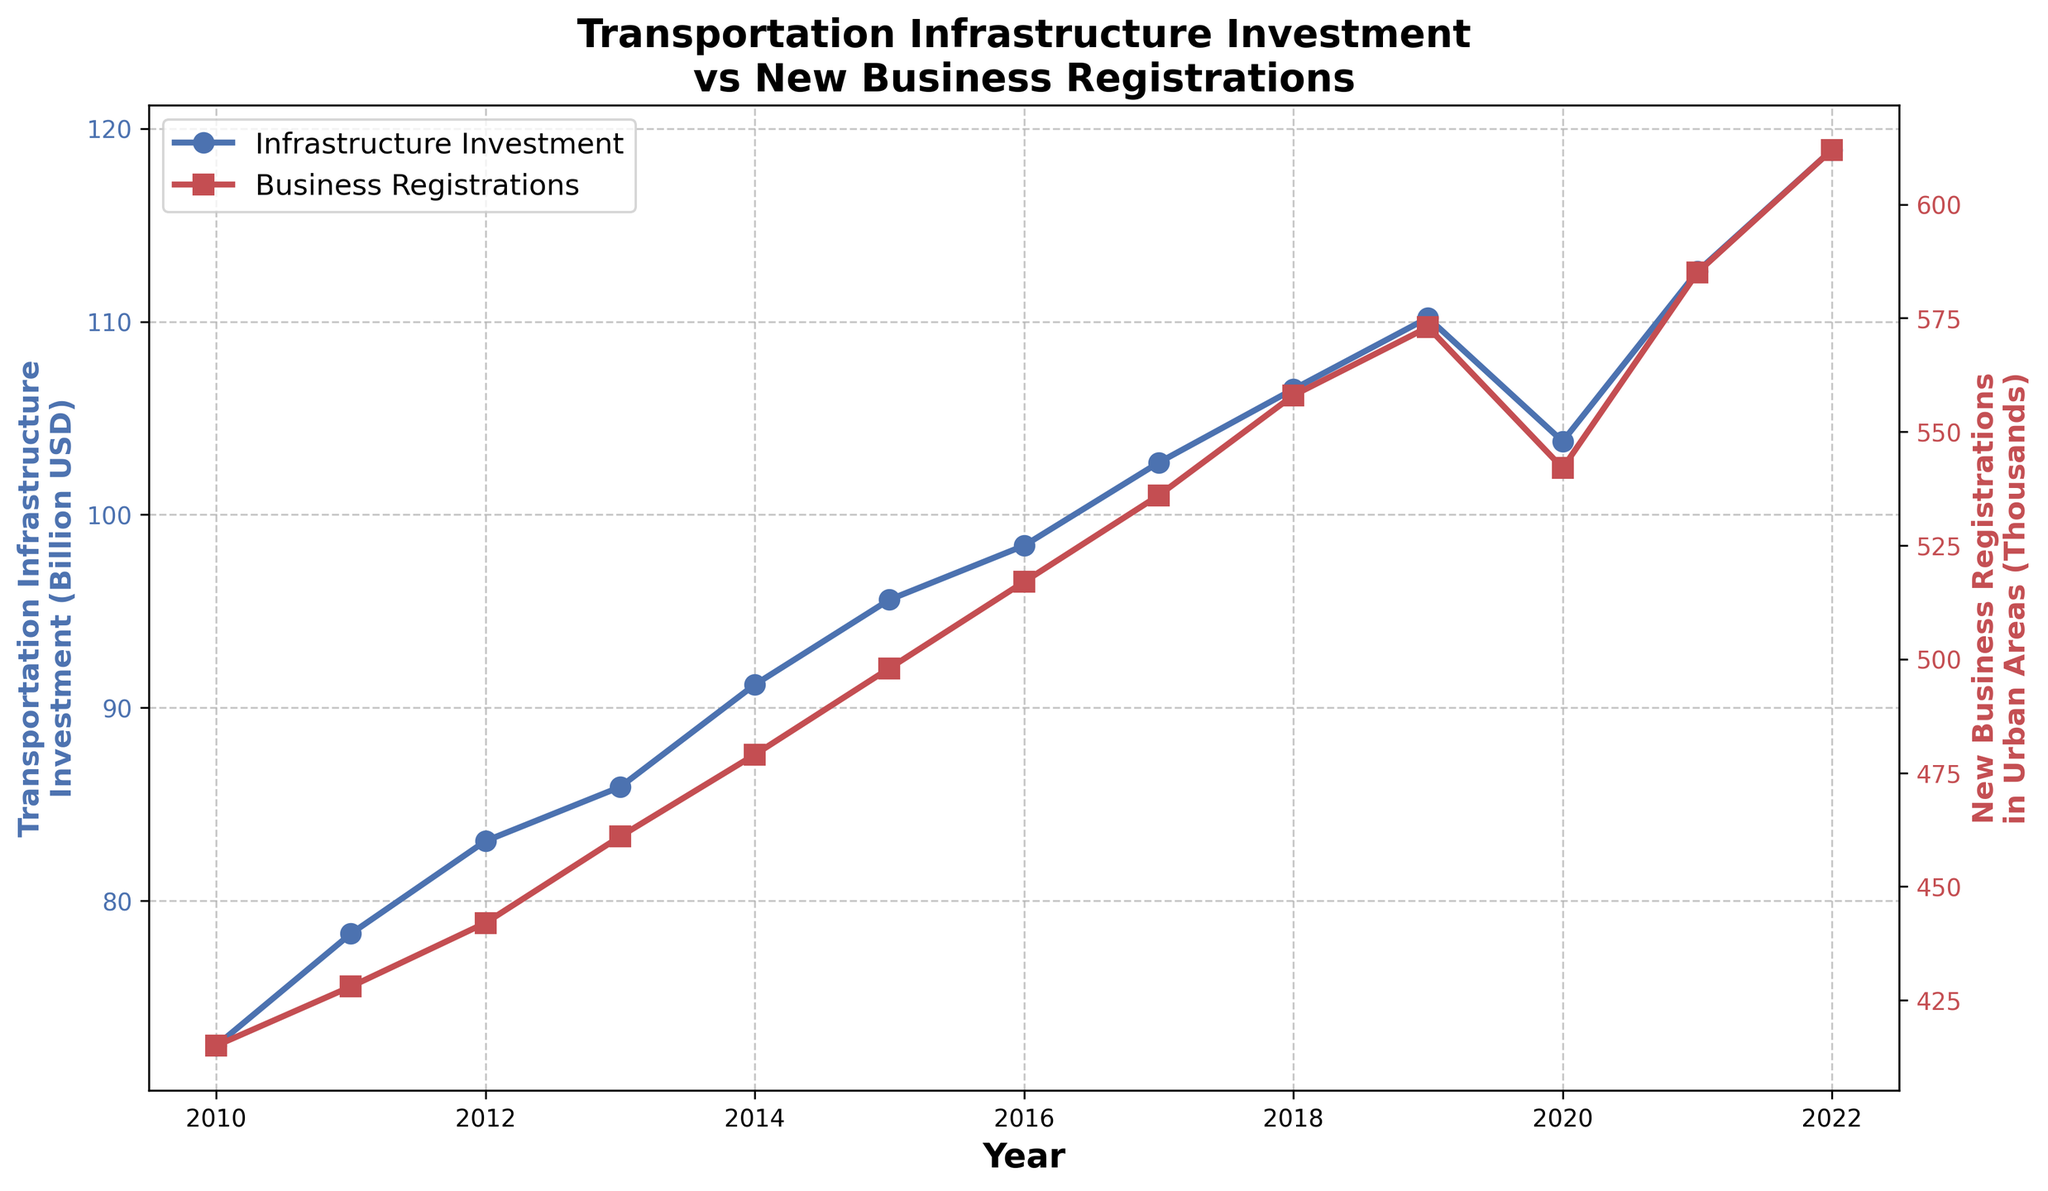What trend can be observed in transportation infrastructure investment between 2010 and 2022? From 2010 to 2022, transportation infrastructure investment shows a general increasing trend, with a notable drop in 2020.
Answer: Increasing trend Compare the transportation infrastructure investment in 2020 with the investment in 2021. Which is higher? In 2020, the investment was approximately $103.8 billion, whereas in 2021, it was $112.6 billion. Thus, 2021's investment is higher.
Answer: 2021 How do the new business registrations in urban areas change from 2010 to 2013? New business registrations increased from 415 thousand in 2010 to 461 thousand in 2013.
Answer: Increased What is the largest year-over-year increase in new business registrations? By looking at the steepest increase in the line representing new business registrations, the highest year-over-year increase occurs between 2021 and 2022, as it rises from 585 thousand to 612 thousand.
Answer: 2021-2022 Calculate the average annual transportation infrastructure investment from 2010 to 2022. Sum of the investments from 2010 to 2022 is (72.5 + 78.3 + 83.1 + 85.9 + 91.2 + 95.6 + 98.4 + 102.7 + 106.5 + 110.2 + 103.8 + 112.6 + 118.9) = 1259.7 billion USD. Divide by the 13 years to get the average: 1259.7 / 13 ≈ 96.9 billion USD.
Answer: 96.9 billion USD Did transportation infrastructure investment exceed $100 billion before 2017? Referencing the investment values, we see that the investment was under $100 billion from 2010 to 2016 and reached $102.7 billion in 2017, so it did not exceed $100 billion before 2017.
Answer: No Identify the years where both transportation infrastructure investment and new business registrations in urban areas have decreased compared to the previous year. The only year where both metrics decreased compared to the previous year is 2020, where investment dropped from $110.2 billion to $103.8 billion and registrations dropped from 573 thousand to 542 thousand.
Answer: 2020 Which has a greater relative change from 2010 to 2022, transportation infrastructure investment or new business registrations? Transportation infrastructure investment increased from $72.5 billion to $118.9 billion, a change of (118.9 - 72.5) / 72.5 ≈ 0.64 or 64%. New business registrations increased from 415 thousand to 612 thousand, a change of (612 - 415) / 415 ≈ 0.476 or 47.6%. Thus, transportation infrastructure investment has a greater relative change.
Answer: Transportation infrastructure investment 